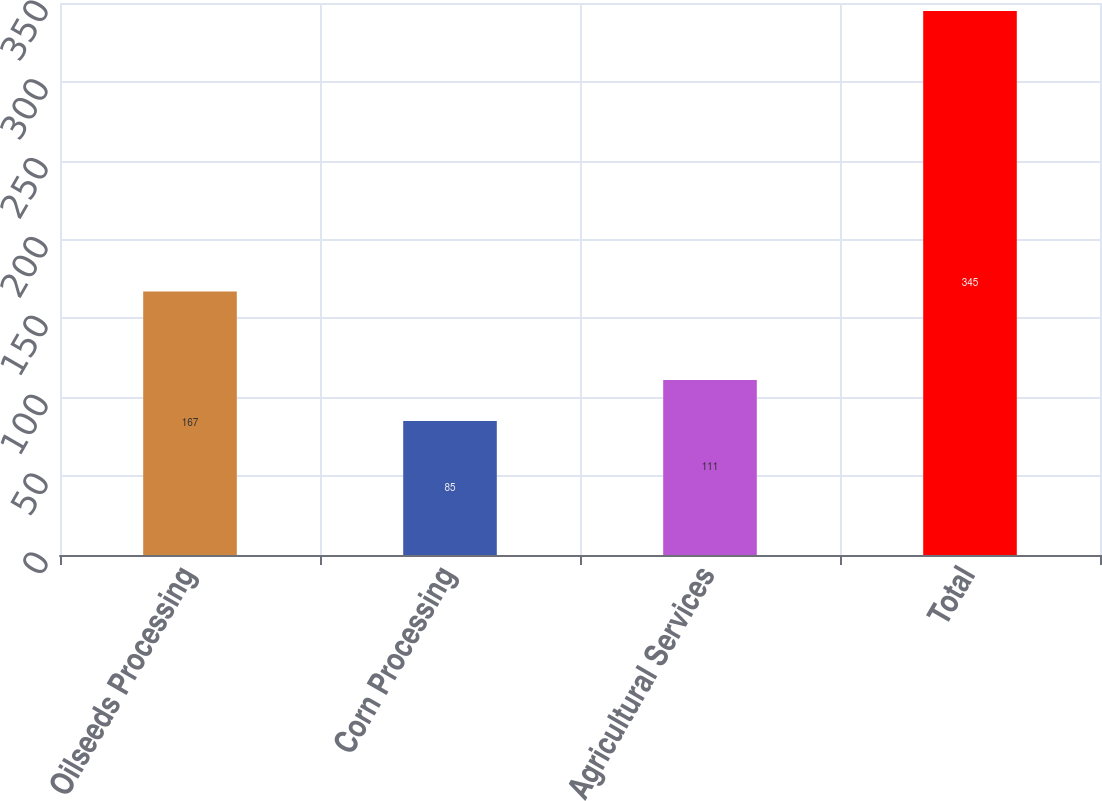Convert chart. <chart><loc_0><loc_0><loc_500><loc_500><bar_chart><fcel>Oilseeds Processing<fcel>Corn Processing<fcel>Agricultural Services<fcel>Total<nl><fcel>167<fcel>85<fcel>111<fcel>345<nl></chart> 